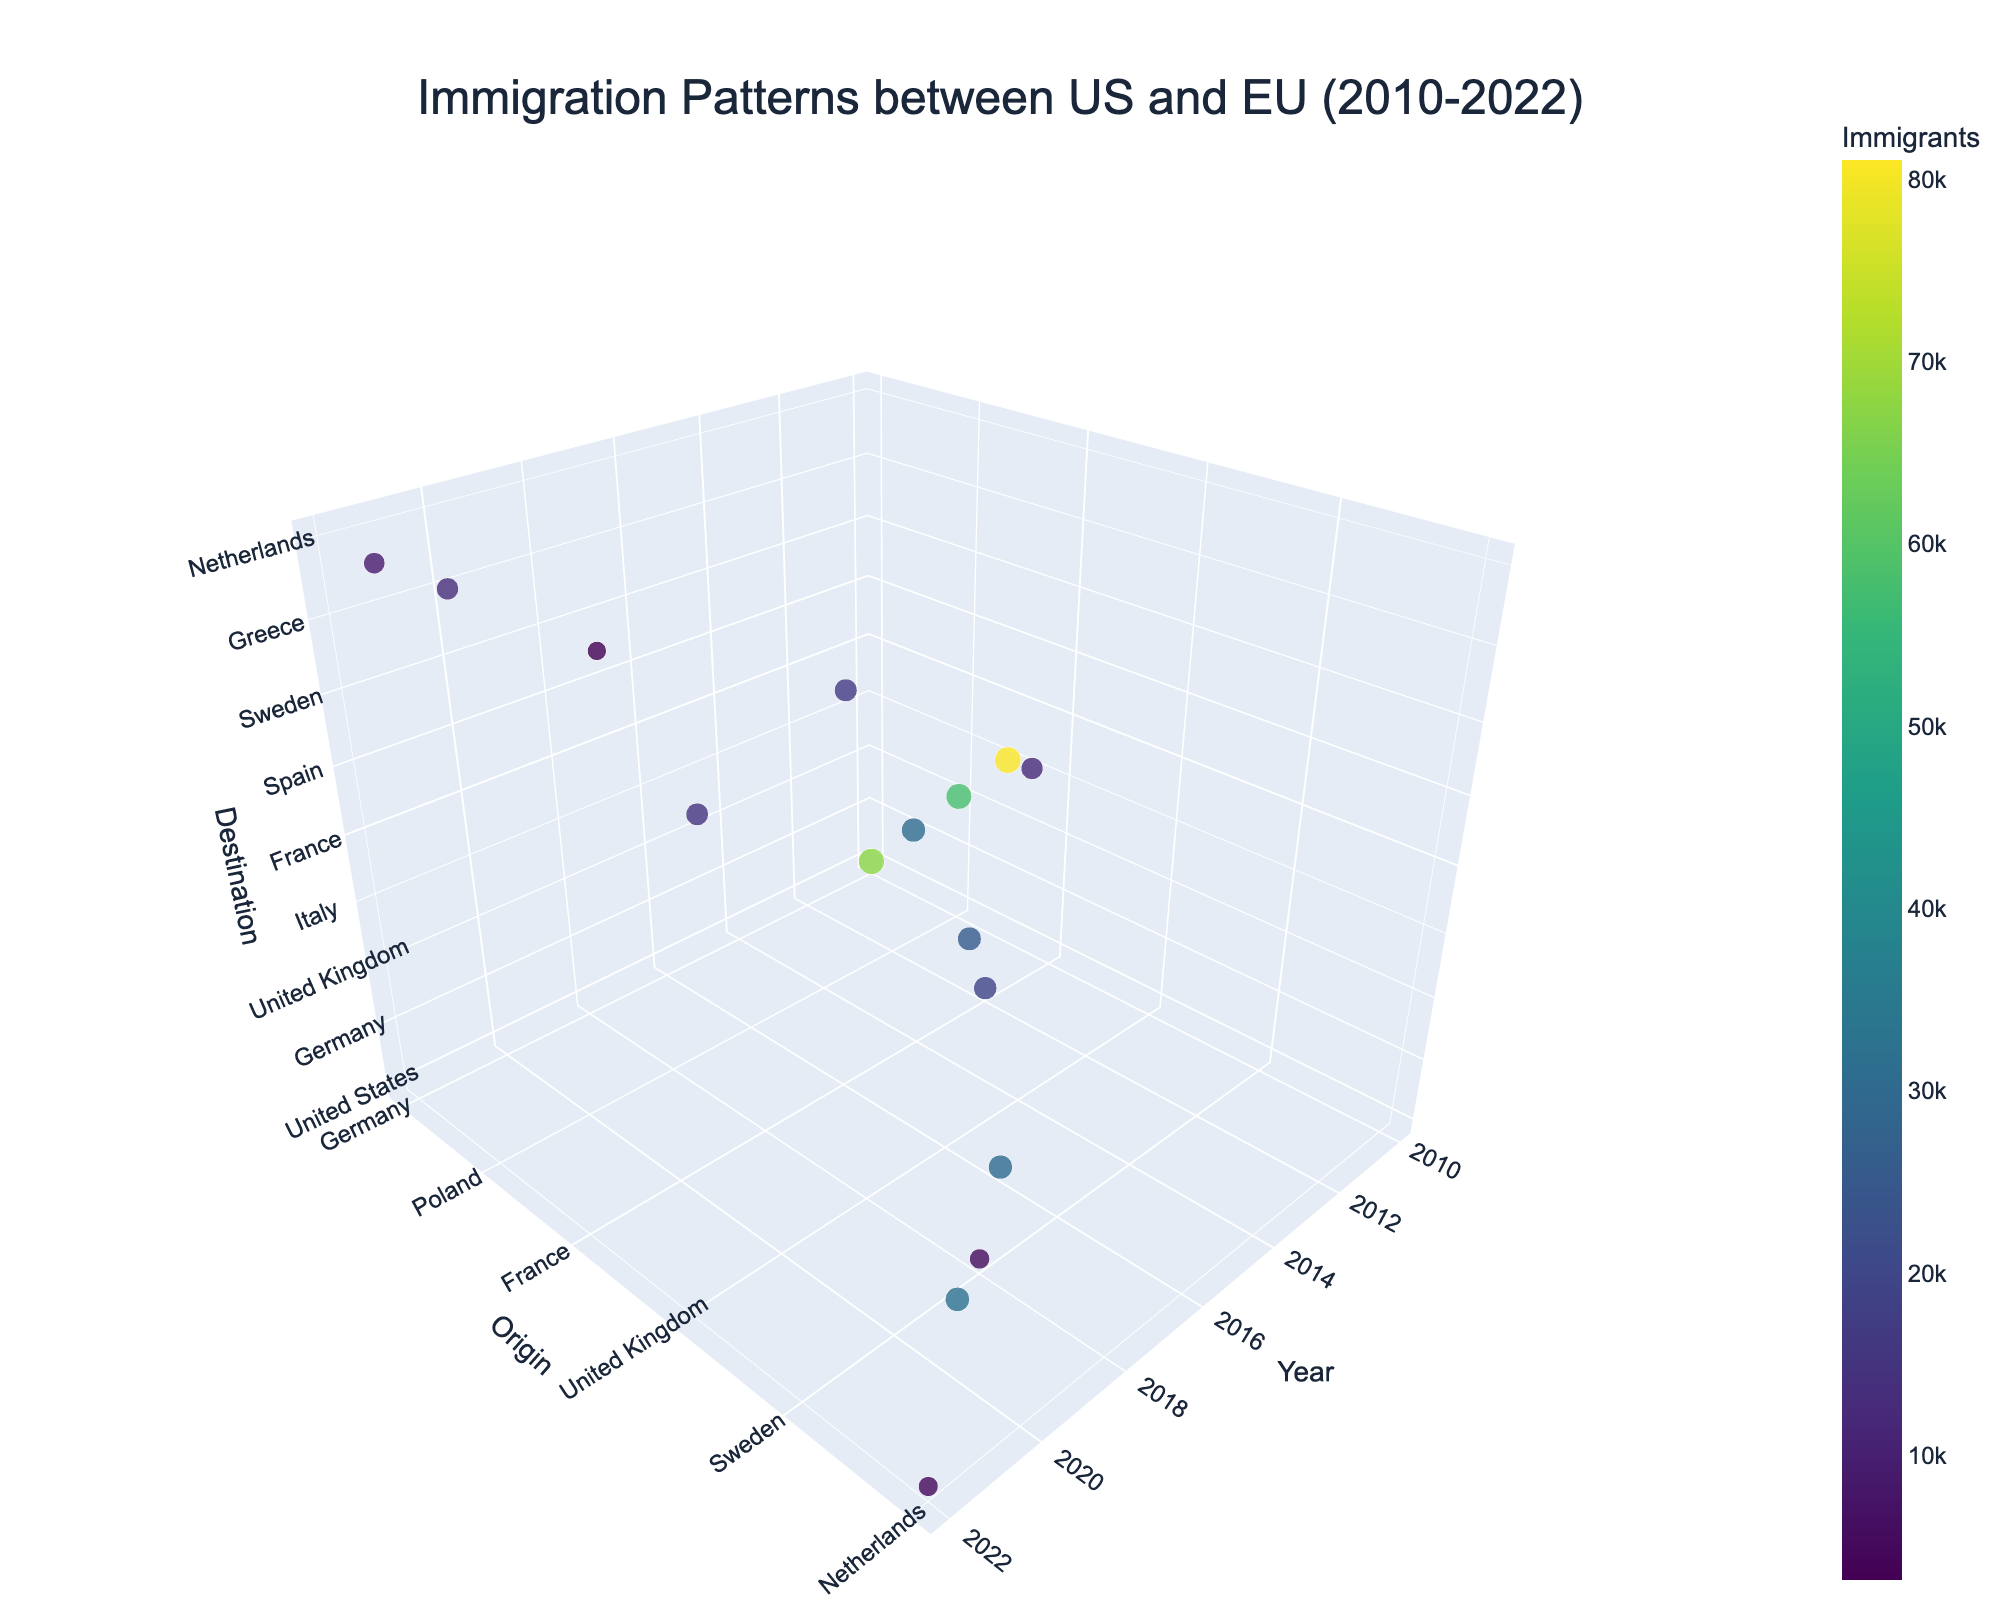What's the title of the 3D plot? The title can be directly observed at the top of the 3D plot, indicating the main theme of the plot.
Answer: Immigration Patterns between US and EU (2010-2022) What are the axis titles in the plot? The axis titles provide context about what is represented along each axis; they can be observed beside each respective axis.
Answer: Year, Origin, Destination Which year had the most migration events represented in the plot? We need to find the year with the most data points (markers) as immigrants recorded in that particular year. By observing the density of points along the 'Year' axis, identify the year with the most representation.
Answer: 2010 Which countries exchanged the most immigrants in 2010? Identify the markers for the year 2010 and compare the sizes of their markers, as larger markers represent more immigrants.
Answer: Romania to Italy Which country pair had the fewest immigrants in 2018? Look for the smaller markers in the year 2018 and compare them to identify the pair with the smallest marker size.
Answer: United States to Sweden Which origin-destination pair has the largest number of immigrants throughout the entire timeline? By comparing all the markers' sizes (since size is proportional to immigrant numbers), identify the pair with the largest marker.
Answer: Romania to Italy How does the number of immigrants from Germany to the United States in 2020 compare to the number from the United States to Germany in 2020? Find the markers for 2020 and compare the size and labels of Germany to the US versus the US to Germany.
Answer: More immigrants from Greece to Germany How has the movement between the United States and Italy changed from 2016 to 2022? Identify markers for movements between these countries in both years and compare their sizes to see growth or reduction in immigrant numbers.
Answer: Decreased What is the difference in immigrant numbers between Spain to the United Kingdom in 2014 and the United Kingdom to Spain in the same year? Retrieve the immigrant counts associated with both markers in 2014 and calculate their difference (25519 - 12056).
Answer: 13463 